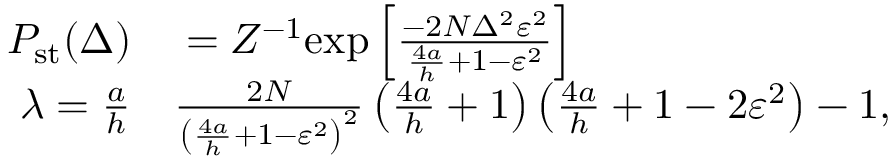Convert formula to latex. <formula><loc_0><loc_0><loc_500><loc_500>\begin{array} { r l } { P _ { s t } ( \Delta ) } & = Z ^ { - 1 } e x p \left [ \frac { - 2 N \Delta ^ { 2 } \varepsilon ^ { 2 } } { \frac { 4 a } { h } + 1 - \varepsilon ^ { 2 } } \right ] } \\ { \lambda = \frac { a } { h } } & \frac { 2 N } { \left ( \frac { 4 a } { h } + 1 - \varepsilon ^ { 2 } \right ) ^ { 2 } } \left ( \frac { 4 a } { h } + 1 \right ) \left ( \frac { 4 a } { h } + 1 - 2 \varepsilon ^ { 2 } \right ) - 1 , } \end{array}</formula> 